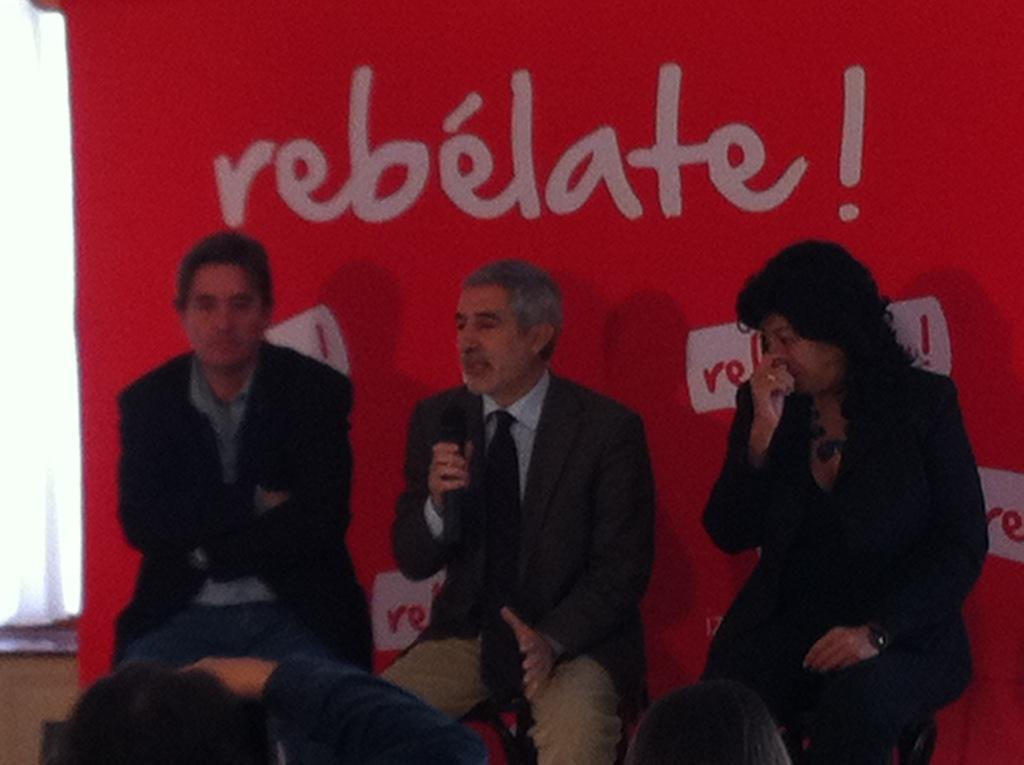What are the people in the image doing? The people in the image are sitting on chairs. Can you describe the person holding an object in the image? There is a person holding a microphone in the image. What can be seen in the background of the image? There is a banner visible in the background of the image. What type of slave is depicted in the image? There is no slave depicted in the image; it features people sitting on chairs and a person holding a microphone. What camera was used to take the image? The camera used to take the image is not visible or mentioned in the image or the provided facts. 